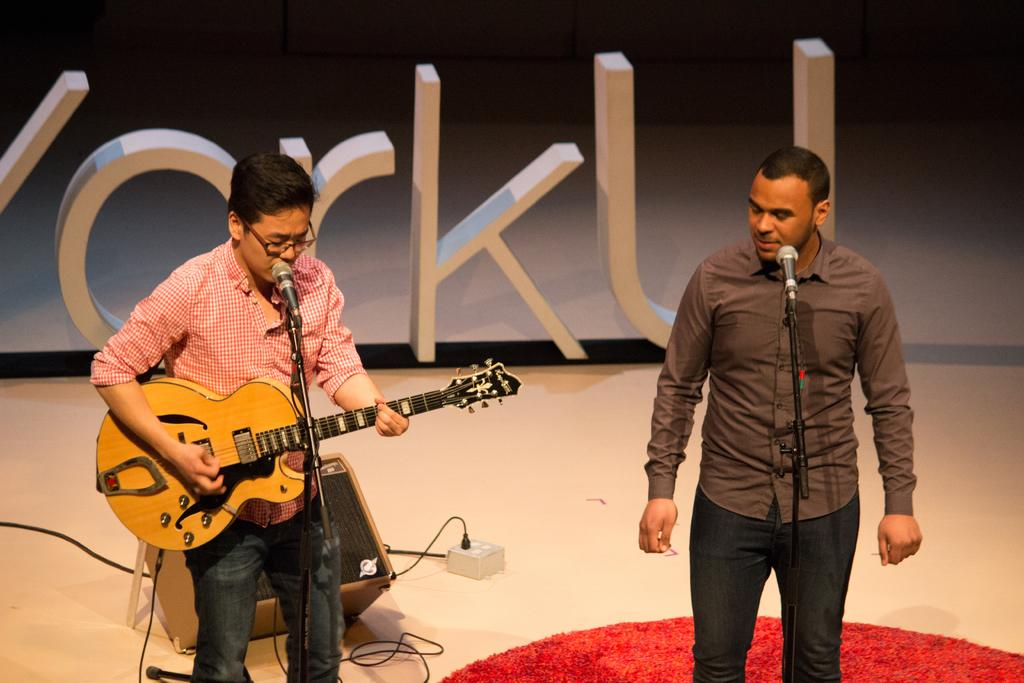How many people are in the image? There are two men in the image. What are the men doing in the image? The men are standing in front of microphones. What instrument is one of the men holding? One man is holding a guitar. What can be seen in the background of the image? There is equipment visible in the background. What else is present in the image besides the men and equipment? There are letters present in the image. What is the opinion of the quartz on the meeting in the image? There is no quartz or meeting present in the image, so it is not possible to determine any opinions. 